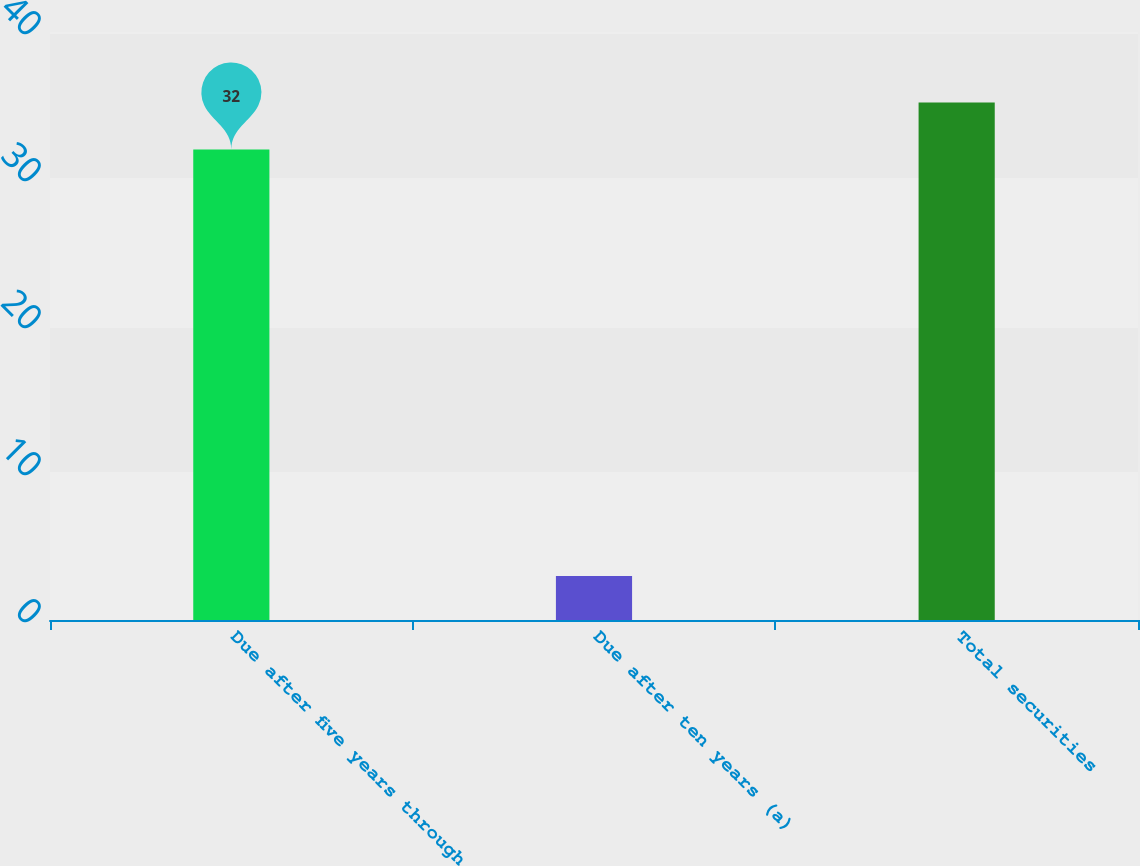Convert chart to OTSL. <chart><loc_0><loc_0><loc_500><loc_500><bar_chart><fcel>Due after five years through<fcel>Due after ten years (a)<fcel>Total securities<nl><fcel>32<fcel>3<fcel>35.2<nl></chart> 